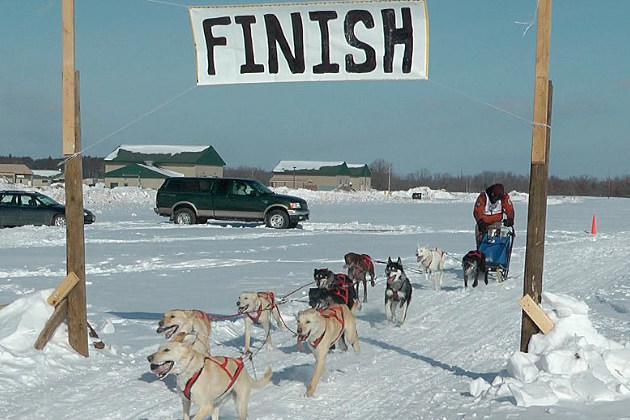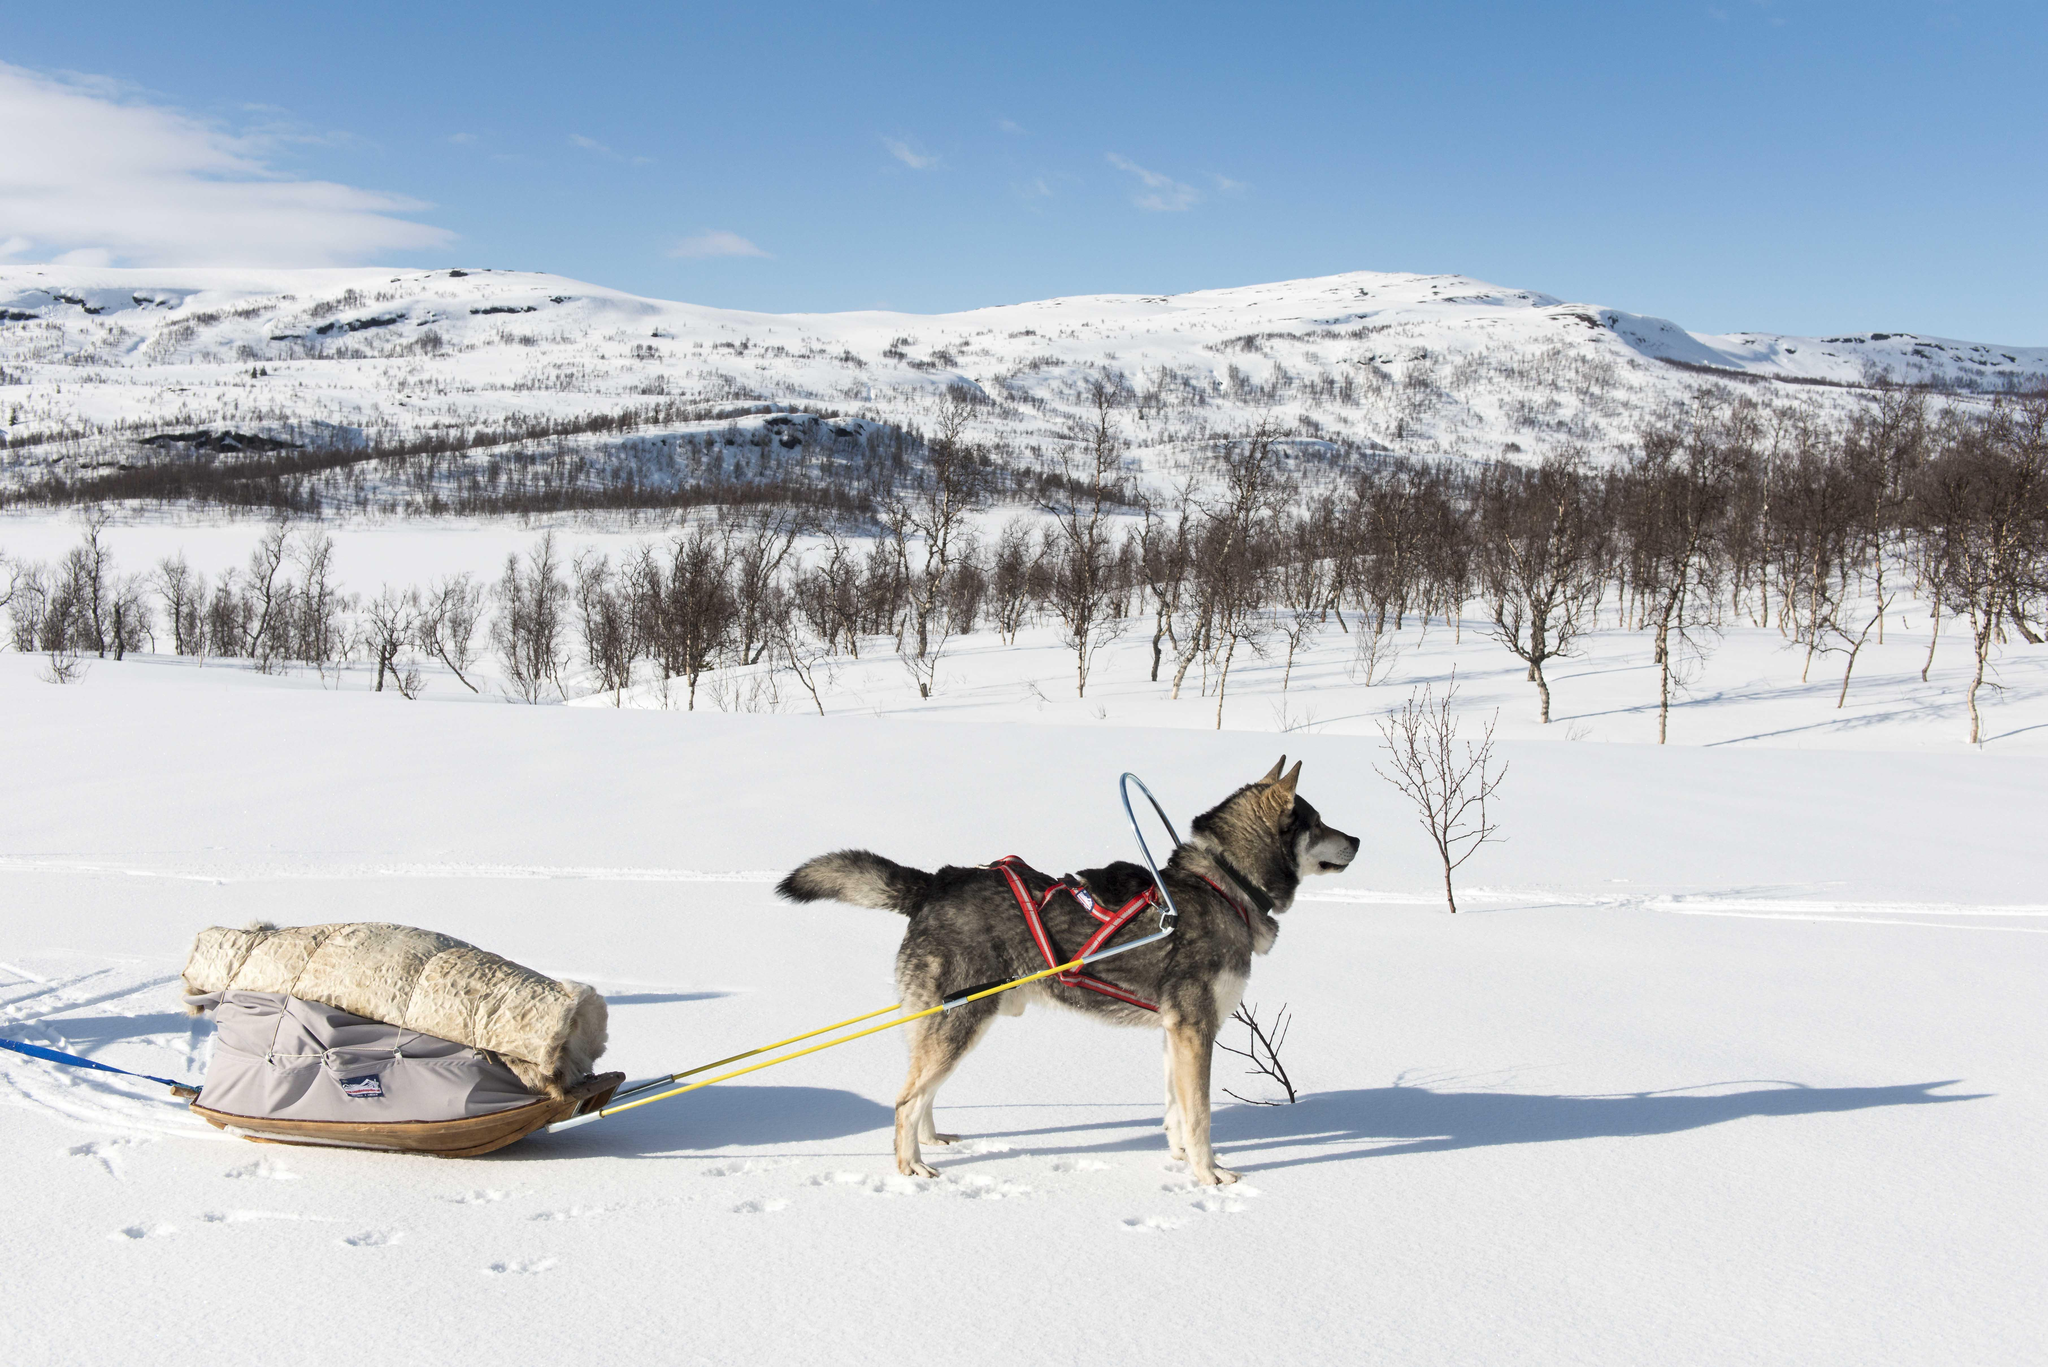The first image is the image on the left, the second image is the image on the right. Analyze the images presented: Is the assertion "There are less than three dogs on the snow in one of the images." valid? Answer yes or no. Yes. 